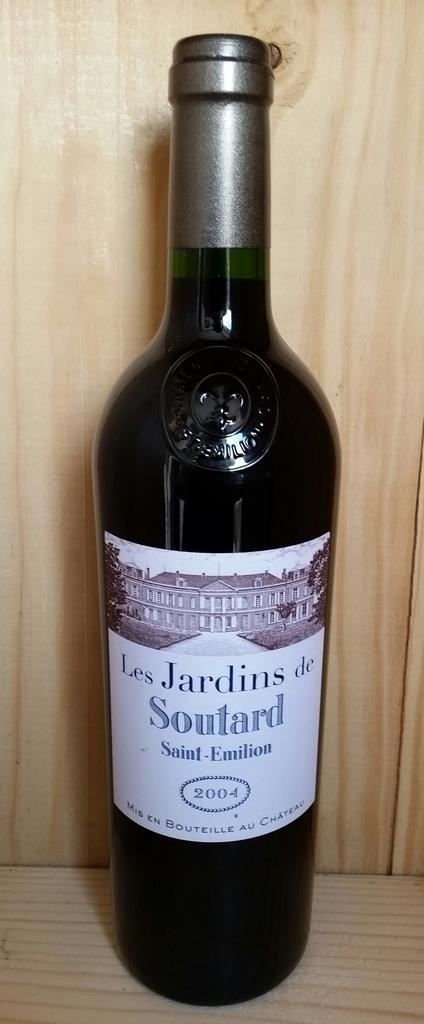<image>
Relay a brief, clear account of the picture shown. A dark bottle of 2004 Soutard wine is on a wooden shelf. 